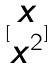Convert formula to latex. <formula><loc_0><loc_0><loc_500><loc_500>[ \begin{matrix} x \\ x ^ { 2 } \end{matrix} ]</formula> 